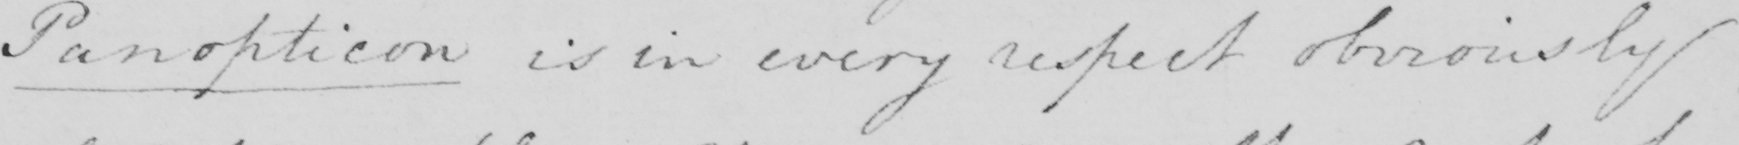Please transcribe the handwritten text in this image. Panopticon is in every respect obviously 